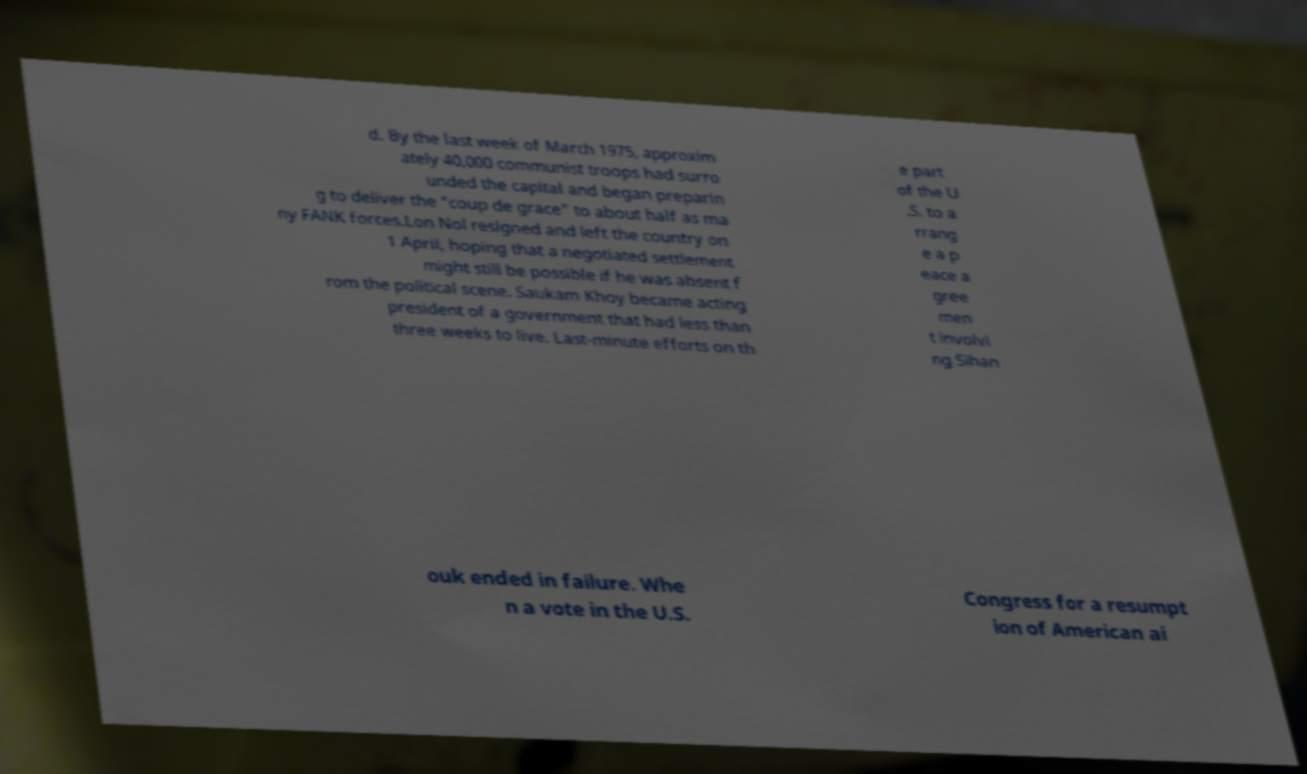There's text embedded in this image that I need extracted. Can you transcribe it verbatim? d. By the last week of March 1975, approxim ately 40,000 communist troops had surro unded the capital and began preparin g to deliver the "coup de grace" to about half as ma ny FANK forces.Lon Nol resigned and left the country on 1 April, hoping that a negotiated settlement might still be possible if he was absent f rom the political scene. Saukam Khoy became acting president of a government that had less than three weeks to live. Last-minute efforts on th e part of the U .S. to a rrang e a p eace a gree men t involvi ng Sihan ouk ended in failure. Whe n a vote in the U.S. Congress for a resumpt ion of American ai 